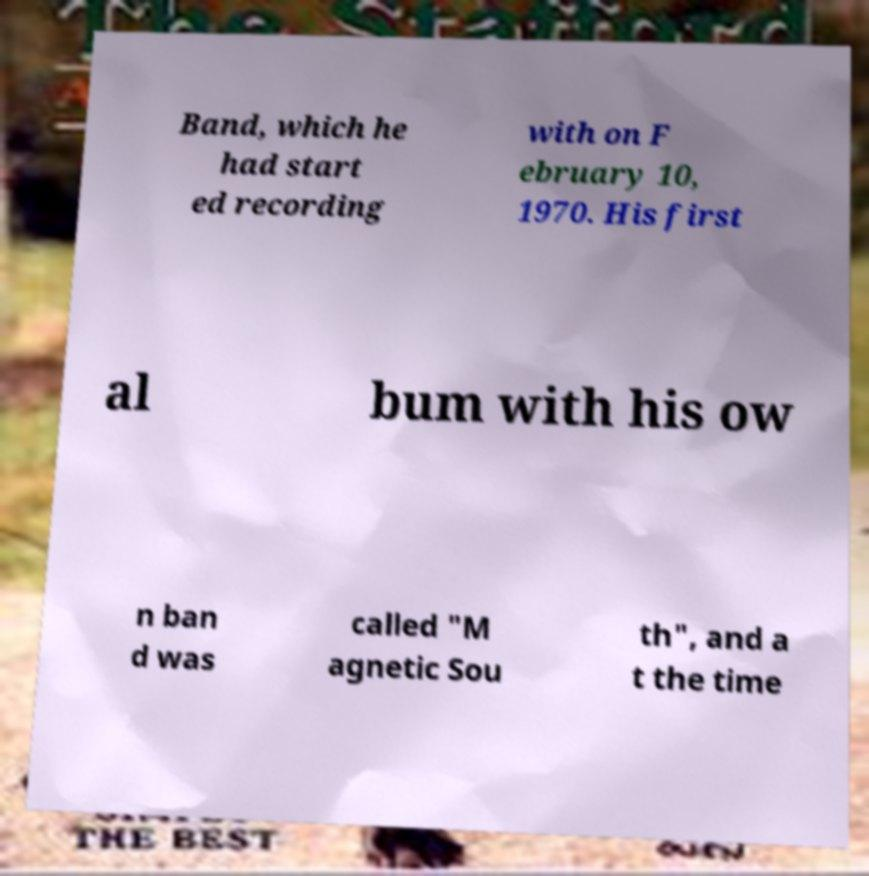Can you read and provide the text displayed in the image?This photo seems to have some interesting text. Can you extract and type it out for me? Band, which he had start ed recording with on F ebruary 10, 1970. His first al bum with his ow n ban d was called "M agnetic Sou th", and a t the time 